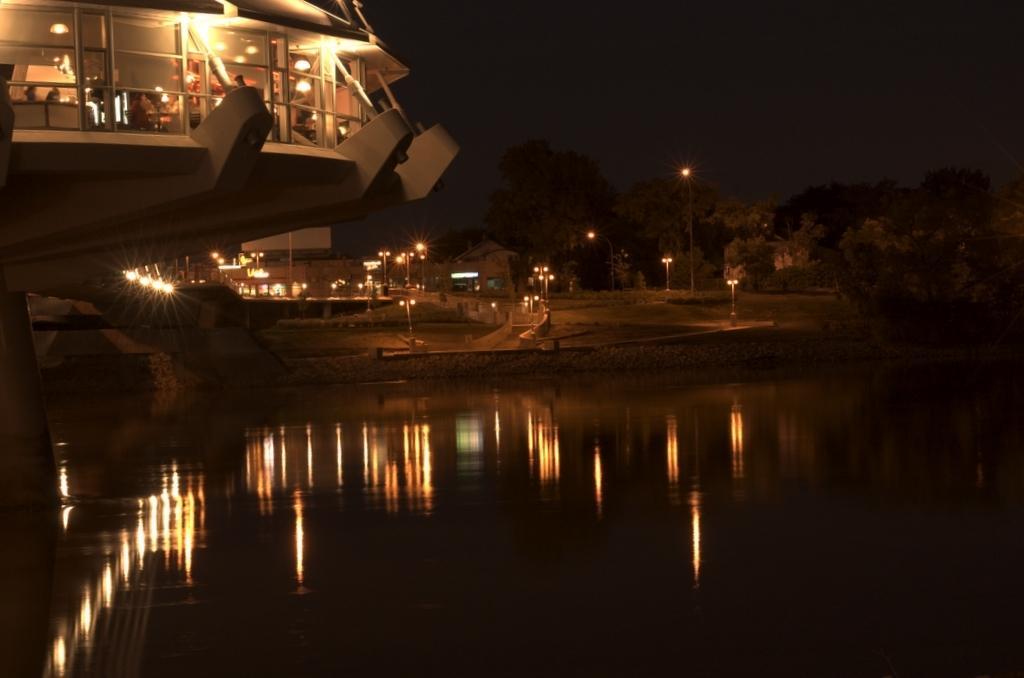In one or two sentences, can you explain what this image depicts? In this image we can see water. In the back there is a building with glass walls. And there are lights. In the background we can see light poles. And there are trees. In the back there is sky. On the water there is reflection of lights. 